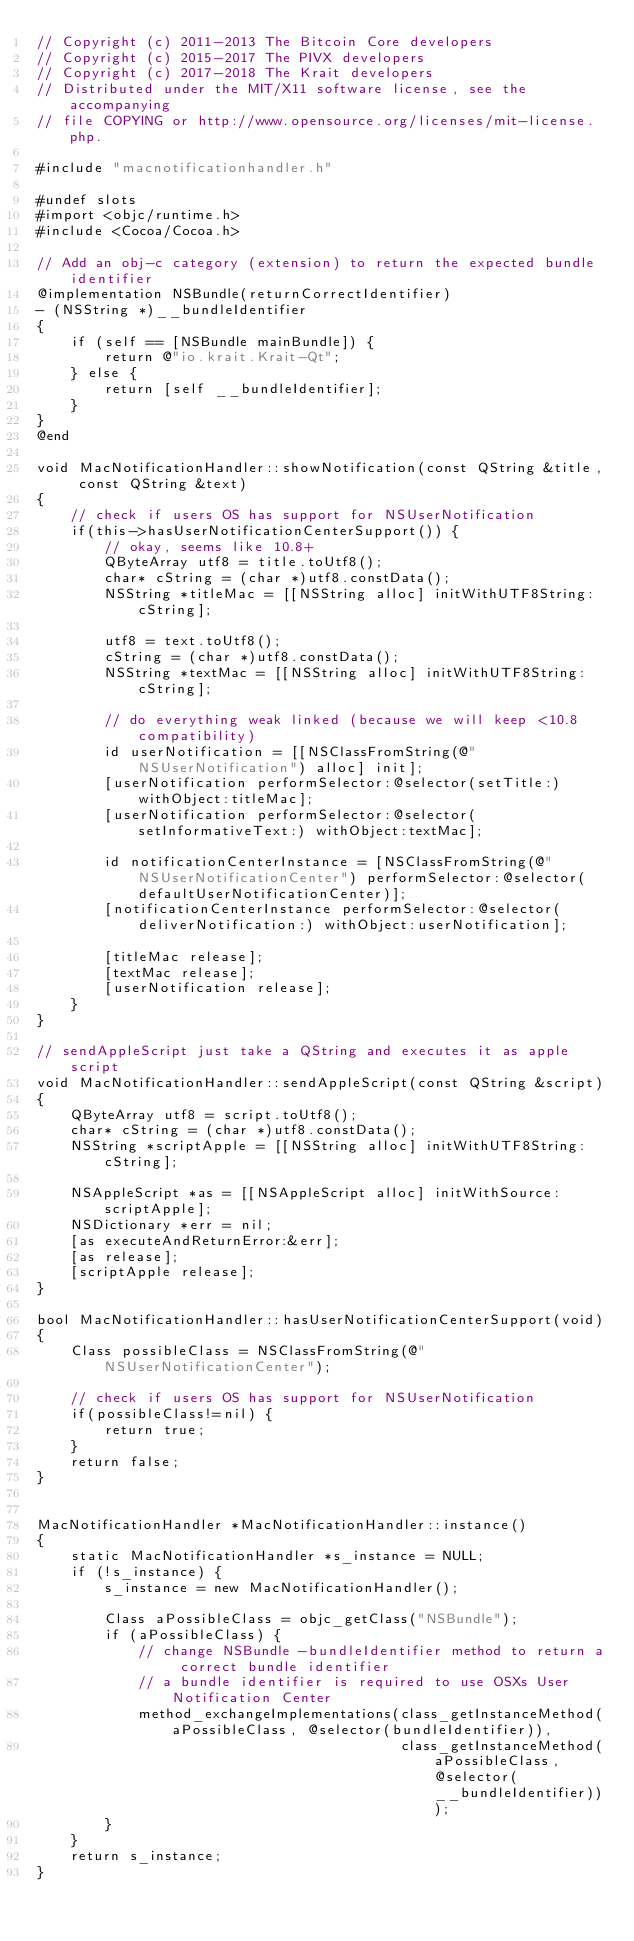Convert code to text. <code><loc_0><loc_0><loc_500><loc_500><_ObjectiveC_>// Copyright (c) 2011-2013 The Bitcoin Core developers
// Copyright (c) 2015-2017 The PIVX developers
// Copyright (c) 2017-2018 The Krait developers
// Distributed under the MIT/X11 software license, see the accompanying
// file COPYING or http://www.opensource.org/licenses/mit-license.php.

#include "macnotificationhandler.h"

#undef slots
#import <objc/runtime.h>
#include <Cocoa/Cocoa.h>

// Add an obj-c category (extension) to return the expected bundle identifier
@implementation NSBundle(returnCorrectIdentifier)
- (NSString *)__bundleIdentifier
{
    if (self == [NSBundle mainBundle]) {
        return @"io.krait.Krait-Qt";
    } else {
        return [self __bundleIdentifier];
    }
}
@end

void MacNotificationHandler::showNotification(const QString &title, const QString &text)
{
    // check if users OS has support for NSUserNotification
    if(this->hasUserNotificationCenterSupport()) {
        // okay, seems like 10.8+
        QByteArray utf8 = title.toUtf8();
        char* cString = (char *)utf8.constData();
        NSString *titleMac = [[NSString alloc] initWithUTF8String:cString];

        utf8 = text.toUtf8();
        cString = (char *)utf8.constData();
        NSString *textMac = [[NSString alloc] initWithUTF8String:cString];

        // do everything weak linked (because we will keep <10.8 compatibility)
        id userNotification = [[NSClassFromString(@"NSUserNotification") alloc] init];
        [userNotification performSelector:@selector(setTitle:) withObject:titleMac];
        [userNotification performSelector:@selector(setInformativeText:) withObject:textMac];

        id notificationCenterInstance = [NSClassFromString(@"NSUserNotificationCenter") performSelector:@selector(defaultUserNotificationCenter)];
        [notificationCenterInstance performSelector:@selector(deliverNotification:) withObject:userNotification];

        [titleMac release];
        [textMac release];
        [userNotification release];
    }
}

// sendAppleScript just take a QString and executes it as apple script
void MacNotificationHandler::sendAppleScript(const QString &script)
{
    QByteArray utf8 = script.toUtf8();
    char* cString = (char *)utf8.constData();
    NSString *scriptApple = [[NSString alloc] initWithUTF8String:cString];

    NSAppleScript *as = [[NSAppleScript alloc] initWithSource:scriptApple];
    NSDictionary *err = nil;
    [as executeAndReturnError:&err];
    [as release];
    [scriptApple release];
}

bool MacNotificationHandler::hasUserNotificationCenterSupport(void)
{
    Class possibleClass = NSClassFromString(@"NSUserNotificationCenter");

    // check if users OS has support for NSUserNotification
    if(possibleClass!=nil) {
        return true;
    }
    return false;
}


MacNotificationHandler *MacNotificationHandler::instance()
{
    static MacNotificationHandler *s_instance = NULL;
    if (!s_instance) {
        s_instance = new MacNotificationHandler();
        
        Class aPossibleClass = objc_getClass("NSBundle");
        if (aPossibleClass) {
            // change NSBundle -bundleIdentifier method to return a correct bundle identifier
            // a bundle identifier is required to use OSXs User Notification Center
            method_exchangeImplementations(class_getInstanceMethod(aPossibleClass, @selector(bundleIdentifier)),
                                           class_getInstanceMethod(aPossibleClass, @selector(__bundleIdentifier)));
        }
    }
    return s_instance;
}
</code> 